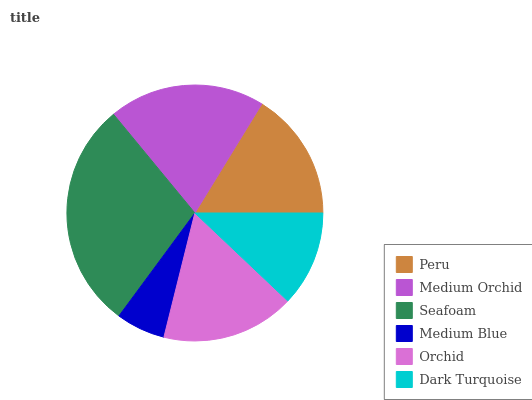Is Medium Blue the minimum?
Answer yes or no. Yes. Is Seafoam the maximum?
Answer yes or no. Yes. Is Medium Orchid the minimum?
Answer yes or no. No. Is Medium Orchid the maximum?
Answer yes or no. No. Is Medium Orchid greater than Peru?
Answer yes or no. Yes. Is Peru less than Medium Orchid?
Answer yes or no. Yes. Is Peru greater than Medium Orchid?
Answer yes or no. No. Is Medium Orchid less than Peru?
Answer yes or no. No. Is Orchid the high median?
Answer yes or no. Yes. Is Peru the low median?
Answer yes or no. Yes. Is Seafoam the high median?
Answer yes or no. No. Is Seafoam the low median?
Answer yes or no. No. 